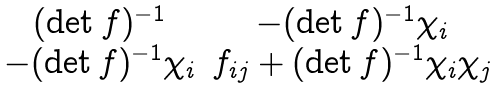Convert formula to latex. <formula><loc_0><loc_0><loc_500><loc_500>\begin{matrix} ( \det f ) ^ { - 1 } & - ( \det f ) ^ { - 1 } \chi _ { i } \\ - ( \det f ) ^ { - 1 } \chi _ { i } & f _ { i j } + ( \det f ) ^ { - 1 } \chi _ { i } \chi _ { j } \end{matrix}</formula> 